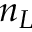<formula> <loc_0><loc_0><loc_500><loc_500>n _ { L }</formula> 